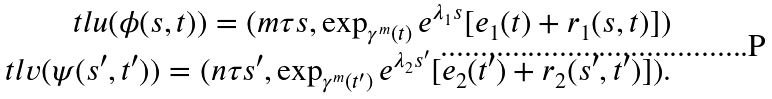Convert formula to latex. <formula><loc_0><loc_0><loc_500><loc_500>\ t l u ( \phi ( s , t ) ) = ( m \tau s , \exp _ { \gamma ^ { m } ( t ) } e ^ { \lambda _ { 1 } s } [ e _ { 1 } ( t ) + r _ { 1 } ( s , t ) ] ) \\ \ t l v ( \psi ( s ^ { \prime } , t ^ { \prime } ) ) = ( n \tau s ^ { \prime } , \exp _ { \gamma ^ { m } ( t ^ { \prime } ) } e ^ { \lambda _ { 2 } s ^ { \prime } } [ e _ { 2 } ( t ^ { \prime } ) + r _ { 2 } ( s ^ { \prime } , t ^ { \prime } ) ] ) .</formula> 